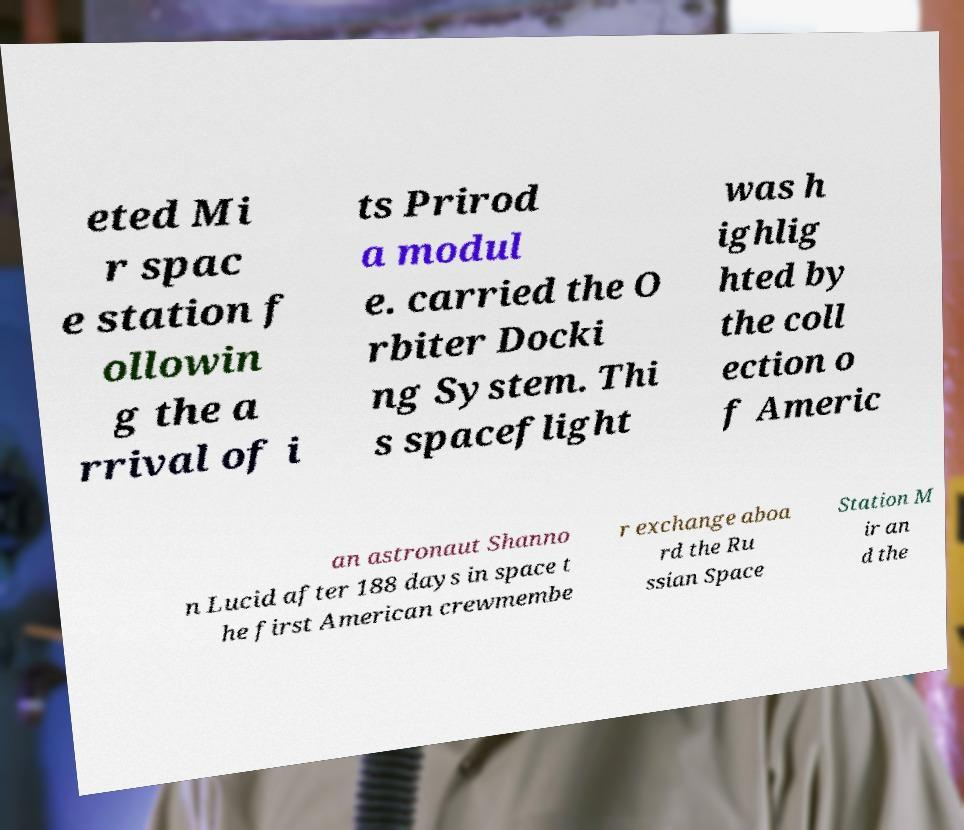Please read and relay the text visible in this image. What does it say? eted Mi r spac e station f ollowin g the a rrival of i ts Prirod a modul e. carried the O rbiter Docki ng System. Thi s spaceflight was h ighlig hted by the coll ection o f Americ an astronaut Shanno n Lucid after 188 days in space t he first American crewmembe r exchange aboa rd the Ru ssian Space Station M ir an d the 